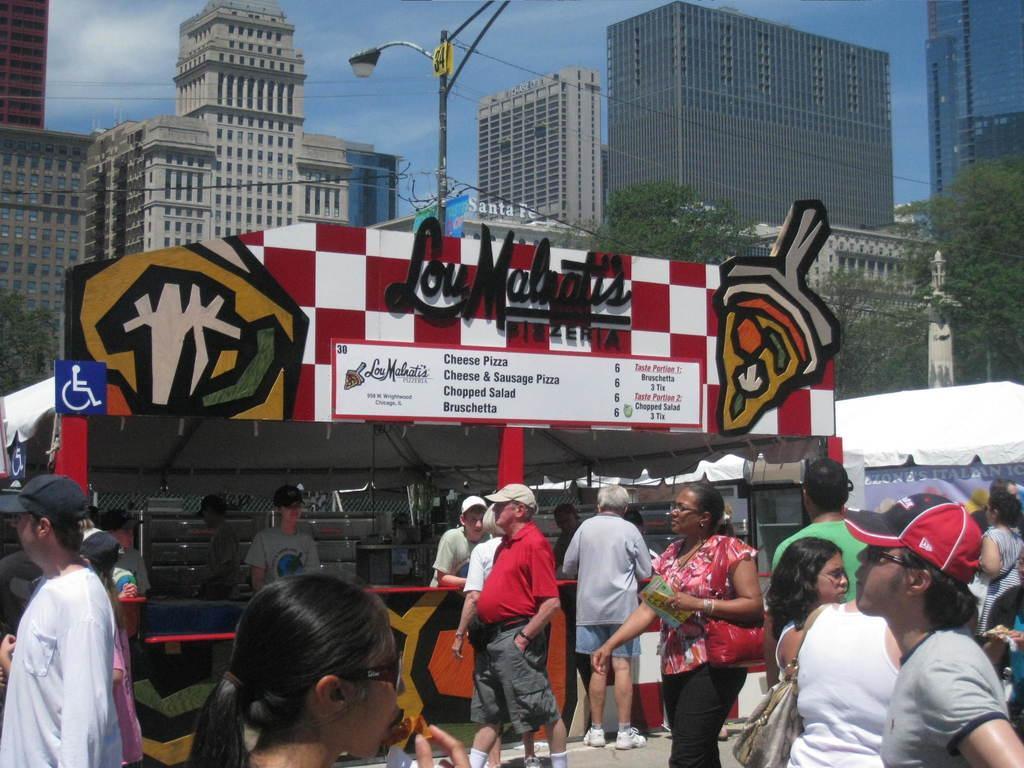Can you describe this image briefly? In the foreground of the picture there are group of people. In the center of the picture there are street light, cables and a shop. In the background there are skyscrapers and sky. 